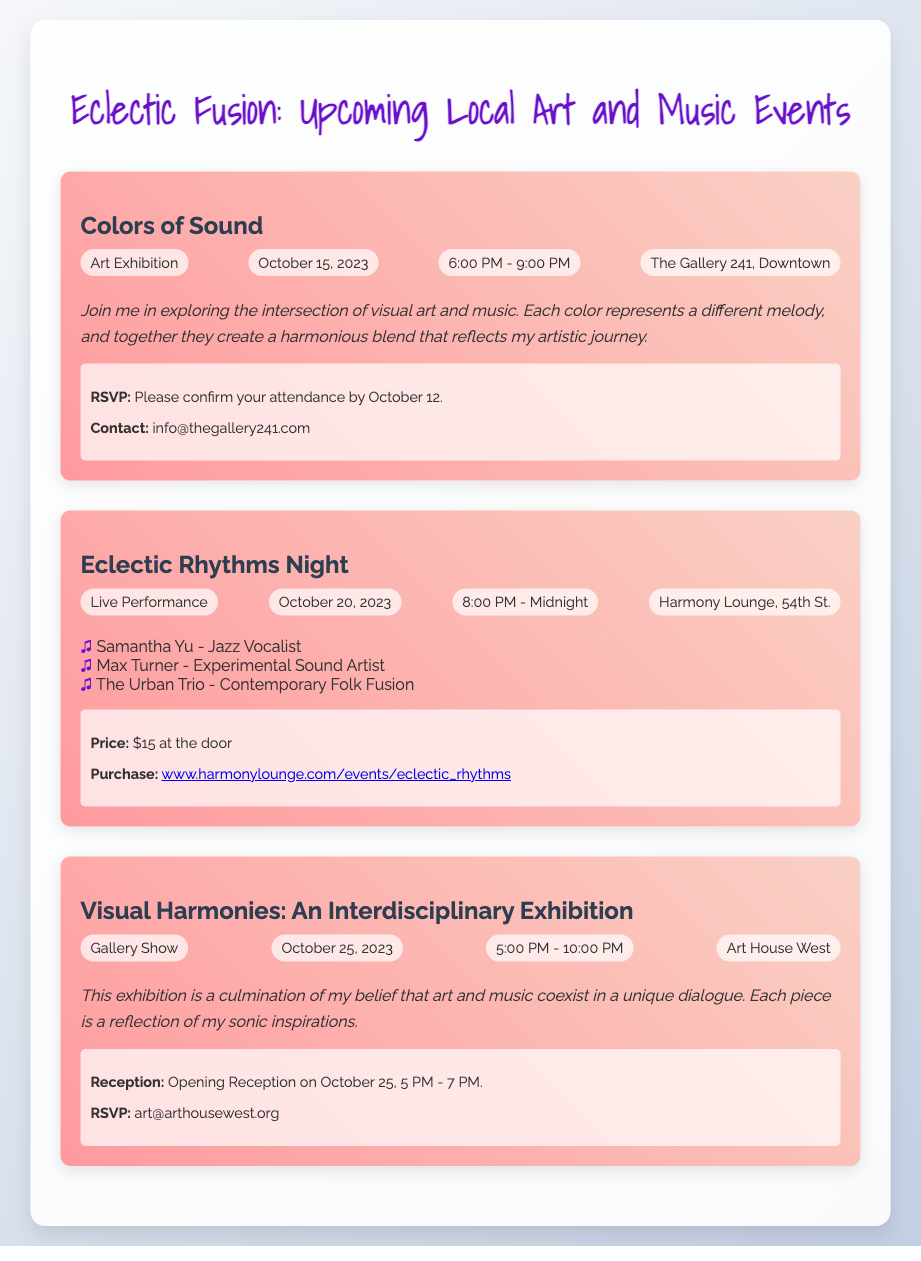What is the title of the first event? The title is listed prominently at the top of each event section, with "Colors of Sound" being the first.
Answer: Colors of Sound When is the Eclectic Rhythms Night scheduled? The date is found in the event details where it mentions the specific performance date for Eclectic Rhythms Night.
Answer: October 20, 2023 What time does the Colors of Sound event start? The start time is noted in the event details for Colors of Sound, where it specifies the timing of the event.
Answer: 6:00 PM Who are the performers at the Eclectic Rhythms Night? The performers are listed in a bulleted format under the event details, providing names and their artistic roles.
Answer: Samantha Yu, Max Turner, The Urban Trio What is the ticket price for the Eclectic Rhythms Night? The ticket pricing information is found in the ticket info section of the event, clearly stated as the cost at the door.
Answer: $15 at the door Which venue is hosting the Visual Harmonies exhibition? The hosting venue is detailed in the event specifics under Visual Harmonies, which names the location.
Answer: Art House West What is the RSVP deadline for the Colors of Sound exhibition? The RSVP deadline is specified in the invitation details for Colors of Sound, indicating when attendees should confirm their attendance.
Answer: October 12 What type of event is occurring on October 25? The type of event is mentioned directly in the title and event type details for that date, providing a clear category.
Answer: Gallery Show 